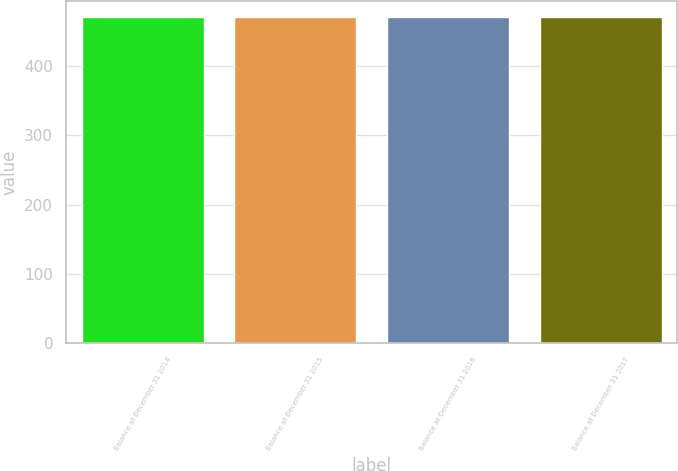Convert chart to OTSL. <chart><loc_0><loc_0><loc_500><loc_500><bar_chart><fcel>Balance at December 31 2014<fcel>Balance at December 31 2015<fcel>Balance at December 31 2016<fcel>Balance at December 31 2017<nl><fcel>470<fcel>470.1<fcel>470.2<fcel>470.3<nl></chart> 